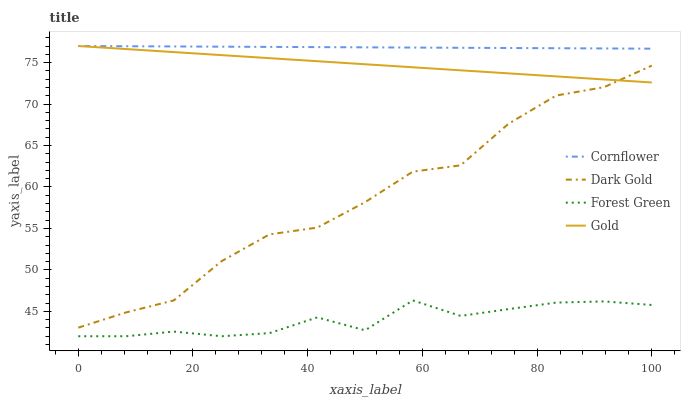Does Forest Green have the minimum area under the curve?
Answer yes or no. Yes. Does Cornflower have the maximum area under the curve?
Answer yes or no. Yes. Does Gold have the minimum area under the curve?
Answer yes or no. No. Does Gold have the maximum area under the curve?
Answer yes or no. No. Is Cornflower the smoothest?
Answer yes or no. Yes. Is Dark Gold the roughest?
Answer yes or no. Yes. Is Forest Green the smoothest?
Answer yes or no. No. Is Forest Green the roughest?
Answer yes or no. No. Does Forest Green have the lowest value?
Answer yes or no. Yes. Does Gold have the lowest value?
Answer yes or no. No. Does Gold have the highest value?
Answer yes or no. Yes. Does Forest Green have the highest value?
Answer yes or no. No. Is Forest Green less than Cornflower?
Answer yes or no. Yes. Is Gold greater than Forest Green?
Answer yes or no. Yes. Does Dark Gold intersect Gold?
Answer yes or no. Yes. Is Dark Gold less than Gold?
Answer yes or no. No. Is Dark Gold greater than Gold?
Answer yes or no. No. Does Forest Green intersect Cornflower?
Answer yes or no. No. 